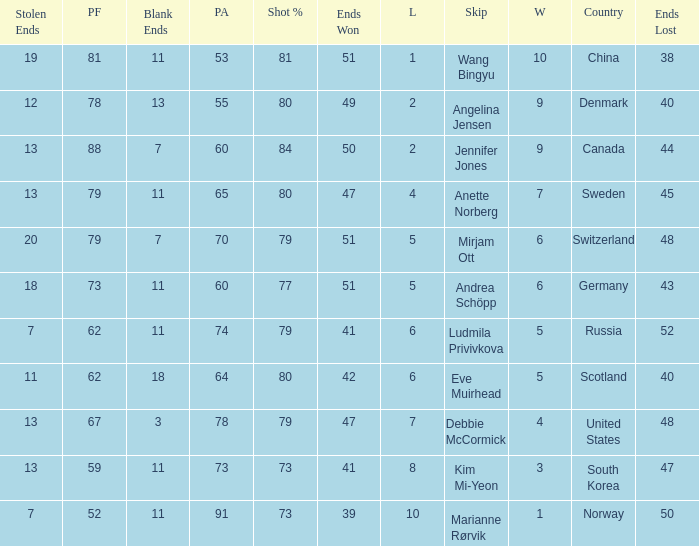When the country was Scotland, how many ends were won? 1.0. 